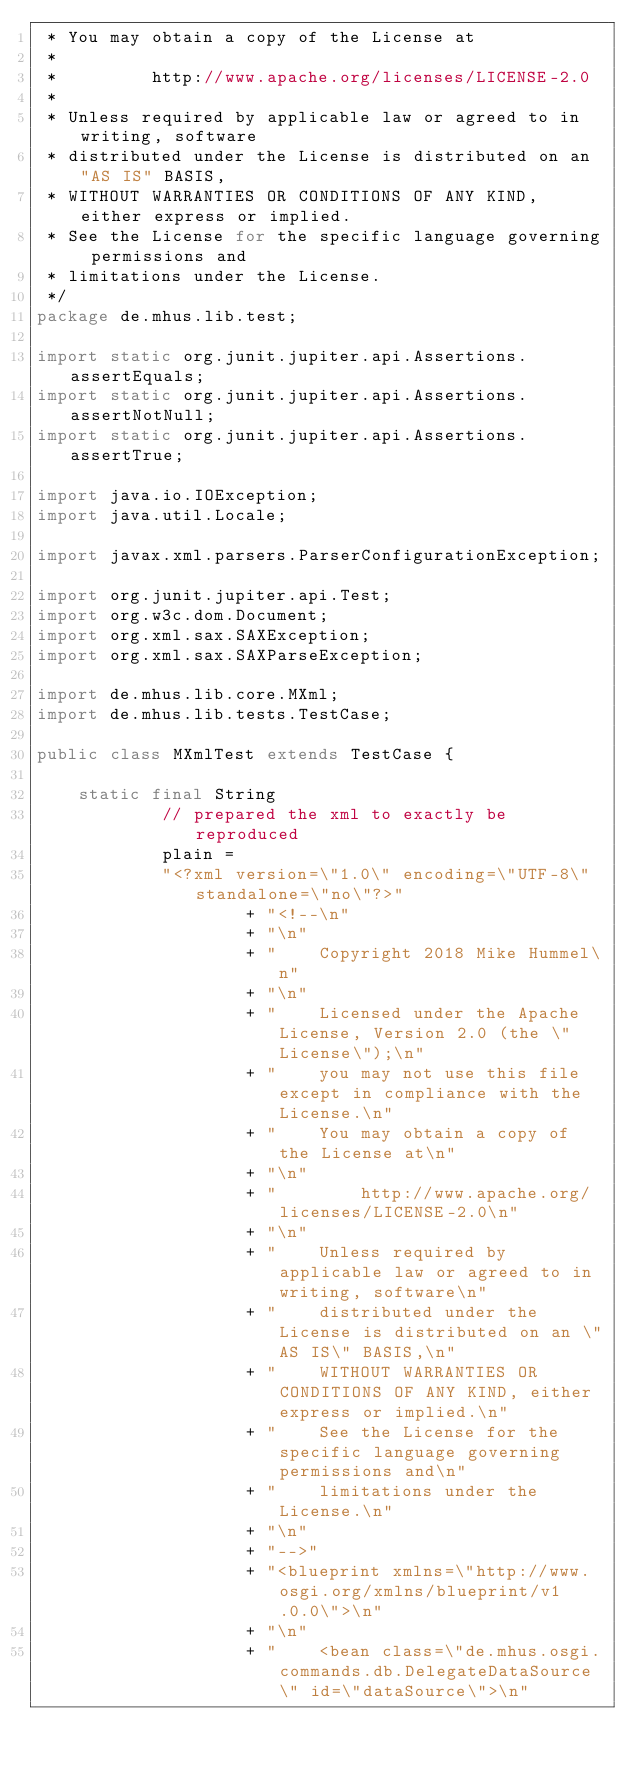Convert code to text. <code><loc_0><loc_0><loc_500><loc_500><_Java_> * You may obtain a copy of the License at
 *
 *         http://www.apache.org/licenses/LICENSE-2.0
 *
 * Unless required by applicable law or agreed to in writing, software
 * distributed under the License is distributed on an "AS IS" BASIS,
 * WITHOUT WARRANTIES OR CONDITIONS OF ANY KIND, either express or implied.
 * See the License for the specific language governing permissions and
 * limitations under the License.
 */
package de.mhus.lib.test;

import static org.junit.jupiter.api.Assertions.assertEquals;
import static org.junit.jupiter.api.Assertions.assertNotNull;
import static org.junit.jupiter.api.Assertions.assertTrue;

import java.io.IOException;
import java.util.Locale;

import javax.xml.parsers.ParserConfigurationException;

import org.junit.jupiter.api.Test;
import org.w3c.dom.Document;
import org.xml.sax.SAXException;
import org.xml.sax.SAXParseException;

import de.mhus.lib.core.MXml;
import de.mhus.lib.tests.TestCase;

public class MXmlTest extends TestCase {

    static final String
            // prepared the xml to exactly be reproduced
            plain =
            "<?xml version=\"1.0\" encoding=\"UTF-8\" standalone=\"no\"?>"
                    + "<!--\n"
                    + "\n"
                    + "    Copyright 2018 Mike Hummel\n"
                    + "\n"
                    + "    Licensed under the Apache License, Version 2.0 (the \"License\");\n"
                    + "    you may not use this file except in compliance with the License.\n"
                    + "    You may obtain a copy of the License at\n"
                    + "\n"
                    + "        http://www.apache.org/licenses/LICENSE-2.0\n"
                    + "\n"
                    + "    Unless required by applicable law or agreed to in writing, software\n"
                    + "    distributed under the License is distributed on an \"AS IS\" BASIS,\n"
                    + "    WITHOUT WARRANTIES OR CONDITIONS OF ANY KIND, either express or implied.\n"
                    + "    See the License for the specific language governing permissions and\n"
                    + "    limitations under the License.\n"
                    + "\n"
                    + "-->"
                    + "<blueprint xmlns=\"http://www.osgi.org/xmlns/blueprint/v1.0.0\">\n"
                    + "\n"
                    + "    <bean class=\"de.mhus.osgi.commands.db.DelegateDataSource\" id=\"dataSource\">\n"</code> 